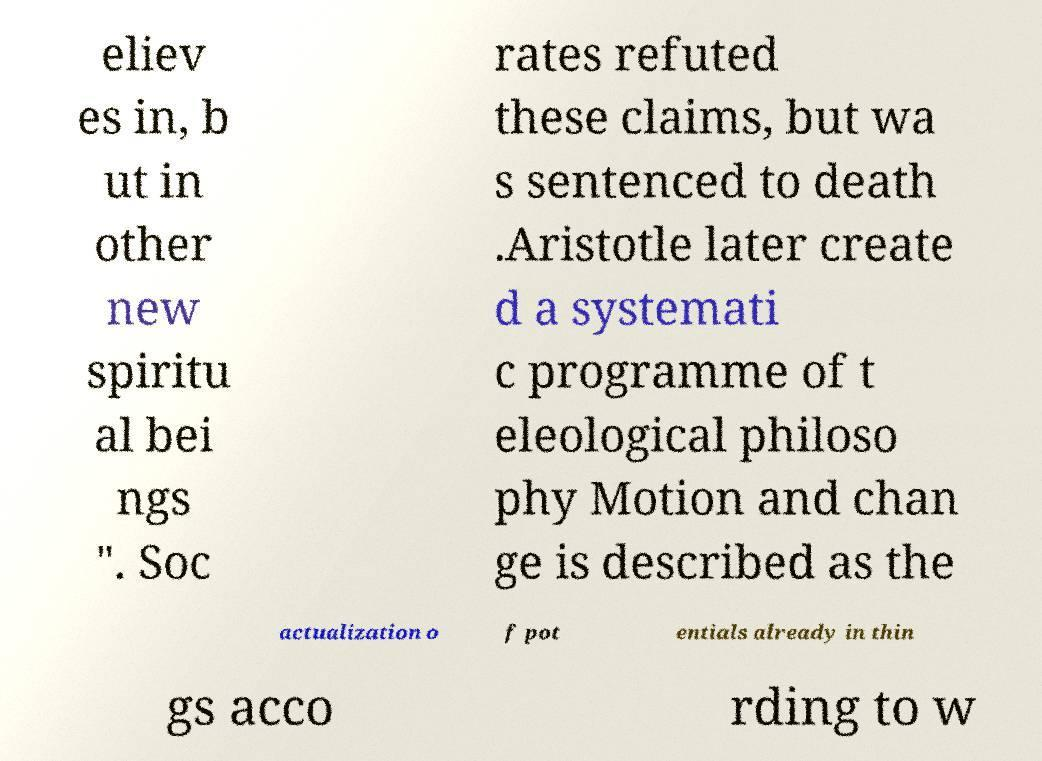Can you read and provide the text displayed in the image?This photo seems to have some interesting text. Can you extract and type it out for me? eliev es in, b ut in other new spiritu al bei ngs ". Soc rates refuted these claims, but wa s sentenced to death .Aristotle later create d a systemati c programme of t eleological philoso phy Motion and chan ge is described as the actualization o f pot entials already in thin gs acco rding to w 